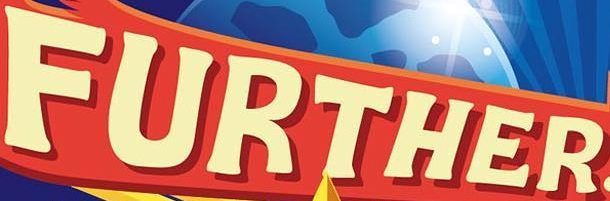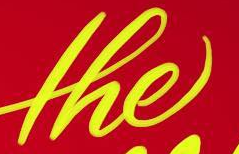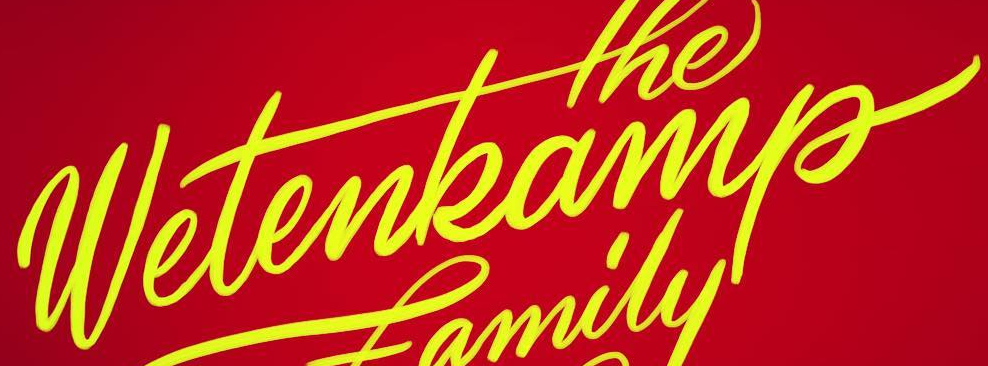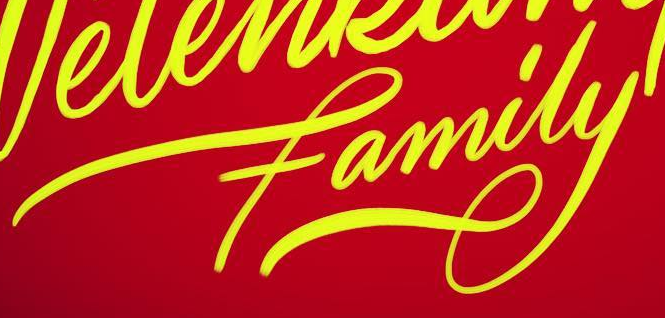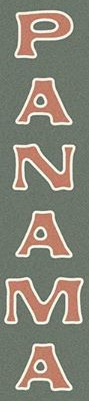What words are shown in these images in order, separated by a semicolon? FURTHER; the; wetenkamp; family; PANAMA 